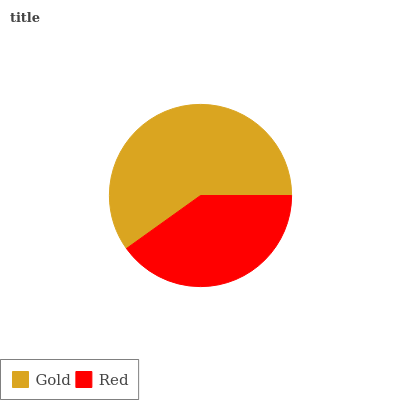Is Red the minimum?
Answer yes or no. Yes. Is Gold the maximum?
Answer yes or no. Yes. Is Red the maximum?
Answer yes or no. No. Is Gold greater than Red?
Answer yes or no. Yes. Is Red less than Gold?
Answer yes or no. Yes. Is Red greater than Gold?
Answer yes or no. No. Is Gold less than Red?
Answer yes or no. No. Is Gold the high median?
Answer yes or no. Yes. Is Red the low median?
Answer yes or no. Yes. Is Red the high median?
Answer yes or no. No. Is Gold the low median?
Answer yes or no. No. 